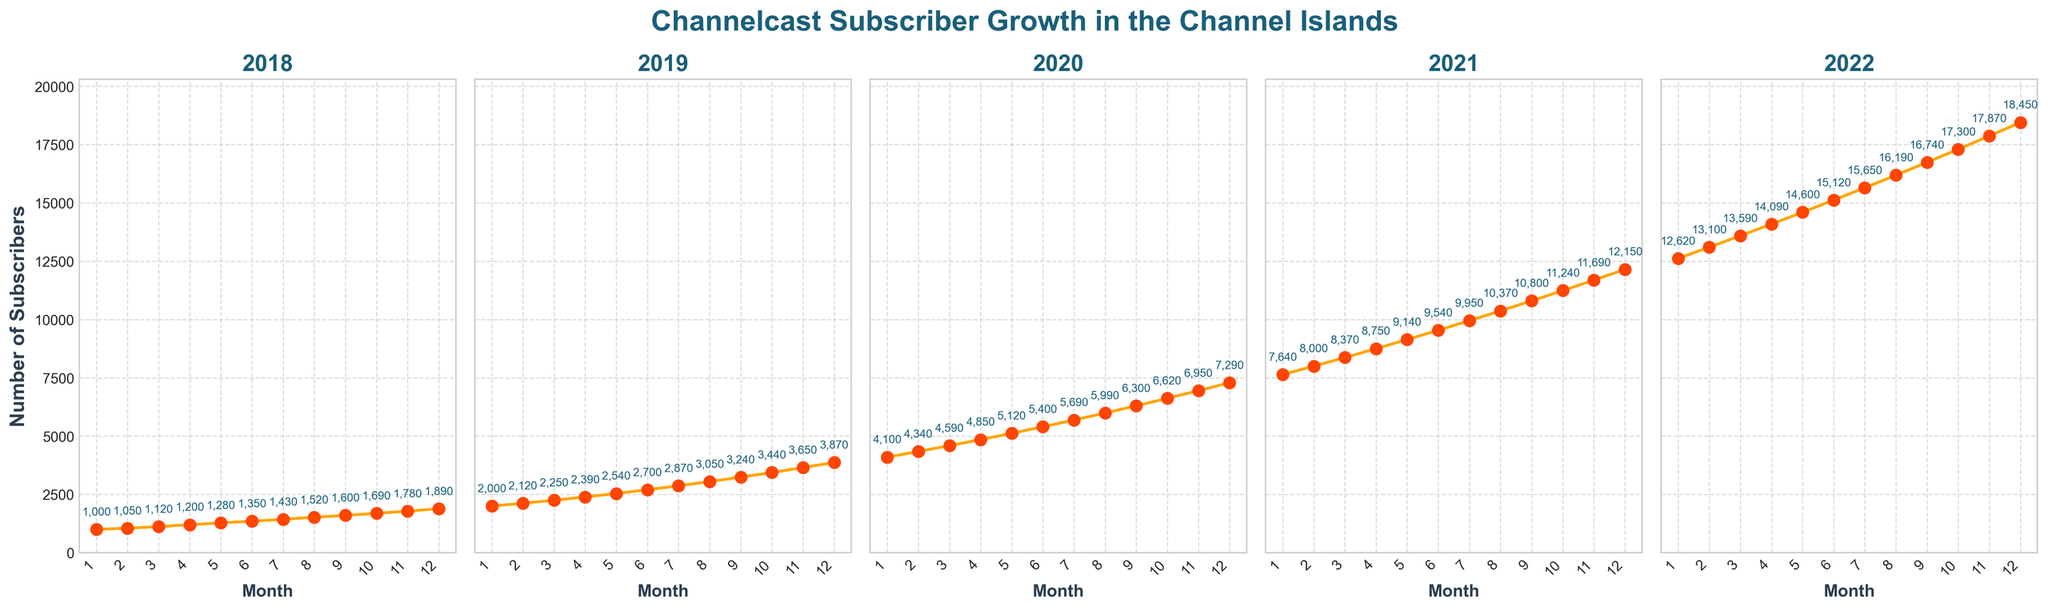What year had the highest absolute increase in subscribers from January to December? To find the year with the highest absolute increase, look at the difference between the January and December subscriber counts for each year. For example, in 2018, the subscriber count increased from 1000 in January to 1890 in December, an increase of 890 subscribers. Calculate this for each year and identify the year with the largest difference.
Answer: 2021 Which year shows the steepest growth curve visually? By visually examining the steepness of the growth curves in the subplots, identify the year where the slope of the line appears steepest, indicating the fastest increase in subscribers.
Answer: 2020 What is the subscriber count in June 2021? Locate the subplot for 2021 and find the data point for June. The number near this point indicates the subscriber count.
Answer: 9540 Which year had the smallest increase in subscribers from January to June? For each year, subtract the January subscriber count from the June subscriber count to determine the half-year increase. Compare these values across all years to find the smallest increase.
Answer: 2018 Compare the subscriber growth from July to December in 2019 and 2020. Which year had more growth in this period? Calculate the difference in subscribers from July to December for both years. For 2019, it’s from 2870 to 3870, an increase of 1000. For 2020, it’s from 5690 to 7290, an increase of 1600. Compare the two values.
Answer: 2020 How many months does it take for the subscribers to double in 2018? Find the first month where the subscriber count in 2018 is approximately double the count in January 2018 (1000). Check the data month by month until you reach a count of around 2000 or more.
Answer: 19 months (July 2019) Which month in 2022 shows the maximum monthly subscriber increase? To determine this, inspect the month-to-month changes in subscriber count within 2022. Identify the month where the increase is the largest.
Answer: December What is the average monthly subscriber growth from January to December in 2020? Calculate the total increase in subscribers from January to December 2020 (7290 - 4100 = 3190), then divide by 12 months to find the average monthly growth.
Answer: Approximately 266 In November 2021, how many more subscribers were there compared to January 2021? Subtract the January 2021 subscriber count from the November 2021 subscriber count (11690 - 7640).
Answer: 4050 Do any two years end with the same number of subscribers in December? Check the subscriber count for December for each year and see if any two values are the same.
Answer: No 